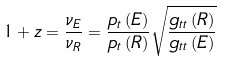<formula> <loc_0><loc_0><loc_500><loc_500>1 + z = \frac { \nu _ { E } } { \nu _ { R } } = \frac { p _ { t } \left ( E \right ) } { p _ { t } \left ( R \right ) } \sqrt { \frac { g _ { t t } \left ( R \right ) } { g _ { t t } \left ( E \right ) } } \</formula> 